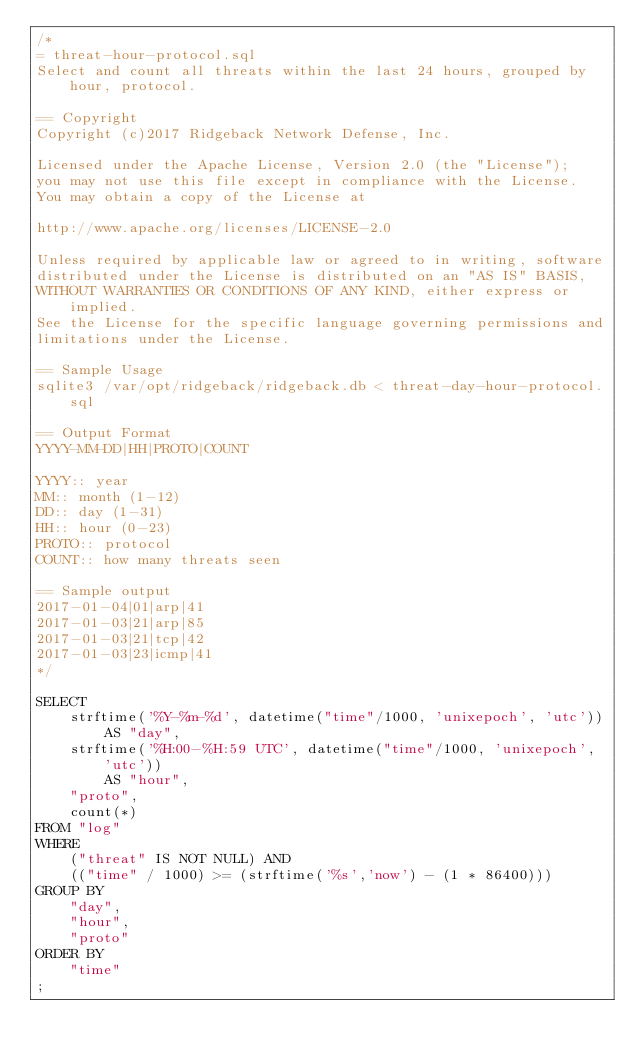Convert code to text. <code><loc_0><loc_0><loc_500><loc_500><_SQL_>/*
= threat-hour-protocol.sql
Select and count all threats within the last 24 hours, grouped by hour, protocol.

== Copyright
Copyright (c)2017 Ridgeback Network Defense, Inc.

Licensed under the Apache License, Version 2.0 (the "License");
you may not use this file except in compliance with the License.
You may obtain a copy of the License at

http://www.apache.org/licenses/LICENSE-2.0

Unless required by applicable law or agreed to in writing, software
distributed under the License is distributed on an "AS IS" BASIS,
WITHOUT WARRANTIES OR CONDITIONS OF ANY KIND, either express or implied.
See the License for the specific language governing permissions and
limitations under the License.

== Sample Usage
sqlite3 /var/opt/ridgeback/ridgeback.db < threat-day-hour-protocol.sql

== Output Format
YYYY-MM-DD|HH|PROTO|COUNT

YYYY:: year
MM:: month (1-12)
DD:: day (1-31)
HH:: hour (0-23)
PROTO:: protocol
COUNT:: how many threats seen

== Sample output
2017-01-04|01|arp|41
2017-01-03|21|arp|85
2017-01-03|21|tcp|42
2017-01-03|23|icmp|41
*/

SELECT
    strftime('%Y-%m-%d', datetime("time"/1000, 'unixepoch', 'utc'))
        AS "day",
    strftime('%H:00-%H:59 UTC', datetime("time"/1000, 'unixepoch', 'utc'))
        AS "hour",
    "proto",
    count(*)
FROM "log"
WHERE
    ("threat" IS NOT NULL) AND
    (("time" / 1000) >= (strftime('%s','now') - (1 * 86400)))
GROUP BY
    "day",
    "hour",
    "proto"
ORDER BY
    "time"
;
</code> 